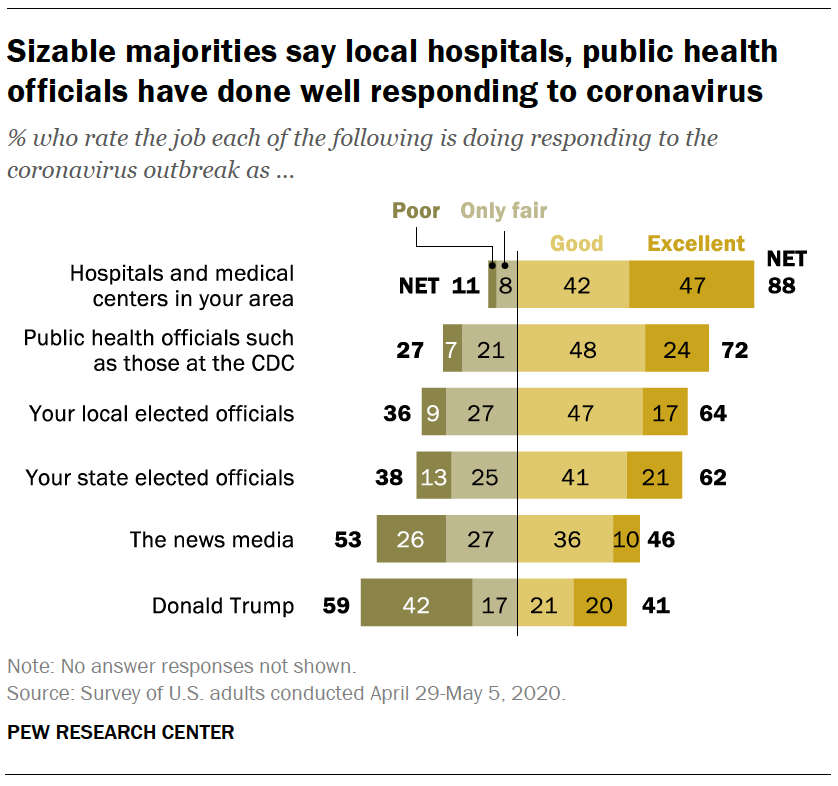Outline some significant characteristics in this image. The least value of a gray bar is 8. The average of the two largest values of the gray bars is 27. 